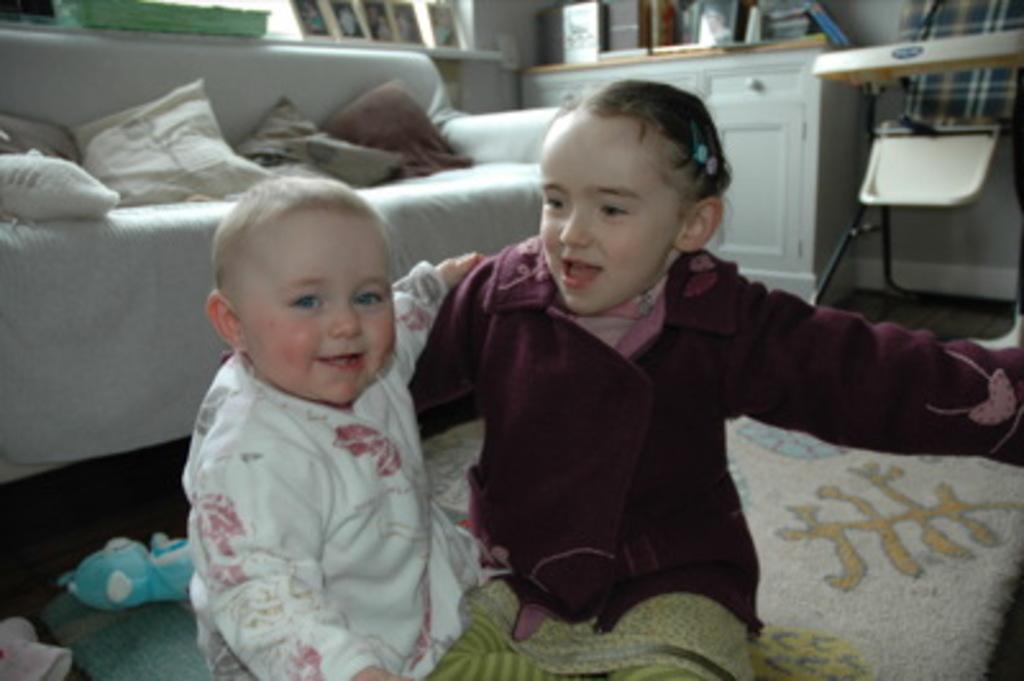In one or two sentences, can you explain what this image depicts? In this image we can see a girl and also a boy smiling and sitting on the carpet. We can also see a toy. In the background we can see the sofa with cushions. We can also see the frames and also the books on the counter. There is a table with a chair. Floor is also visible in this image. 